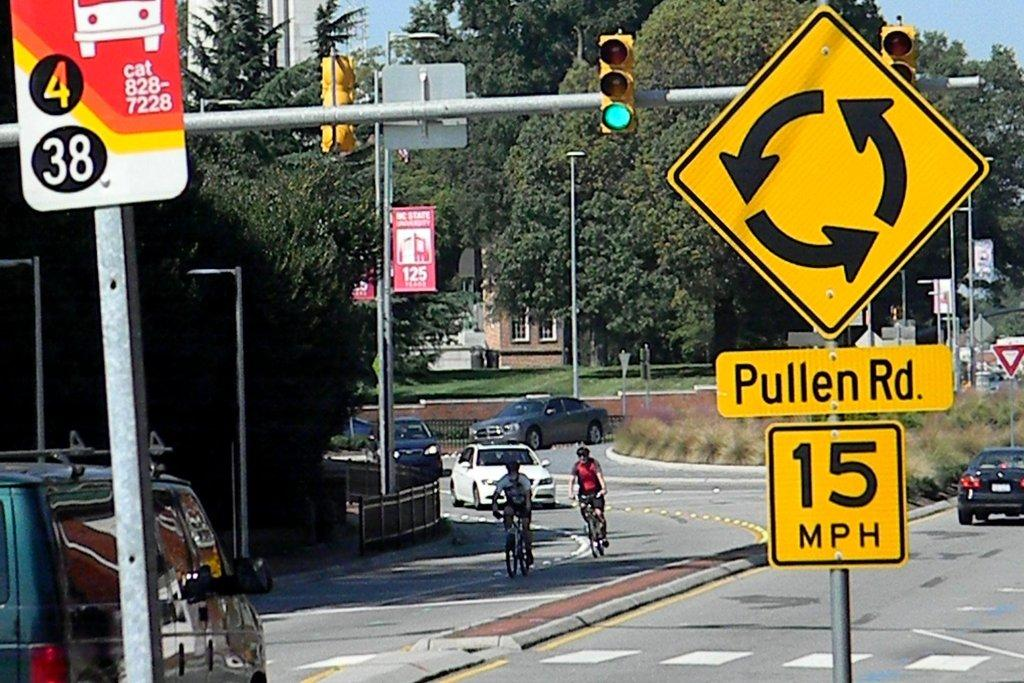<image>
Share a concise interpretation of the image provided. a pullen rd sign that is above the ground 